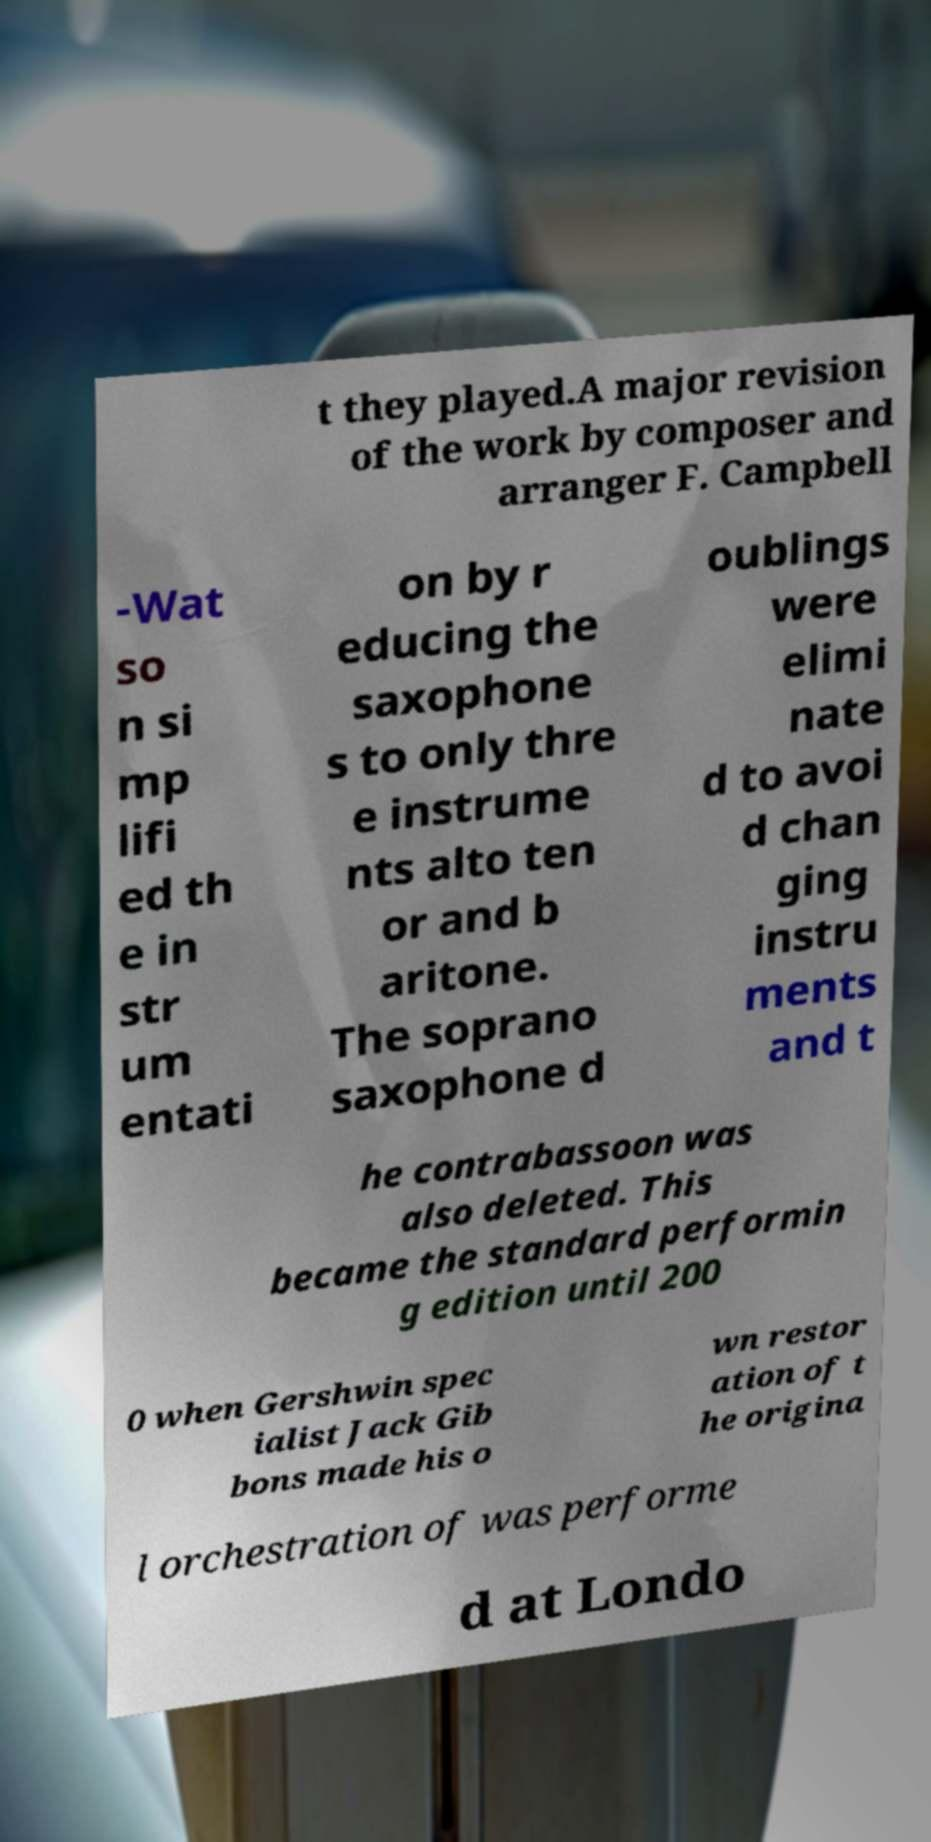For documentation purposes, I need the text within this image transcribed. Could you provide that? t they played.A major revision of the work by composer and arranger F. Campbell -Wat so n si mp lifi ed th e in str um entati on by r educing the saxophone s to only thre e instrume nts alto ten or and b aritone. The soprano saxophone d oublings were elimi nate d to avoi d chan ging instru ments and t he contrabassoon was also deleted. This became the standard performin g edition until 200 0 when Gershwin spec ialist Jack Gib bons made his o wn restor ation of t he origina l orchestration of was performe d at Londo 